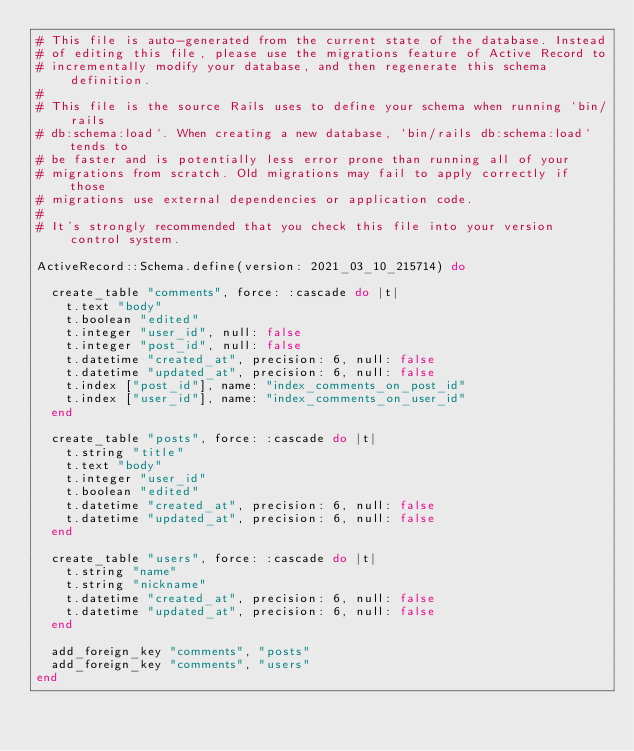Convert code to text. <code><loc_0><loc_0><loc_500><loc_500><_Ruby_># This file is auto-generated from the current state of the database. Instead
# of editing this file, please use the migrations feature of Active Record to
# incrementally modify your database, and then regenerate this schema definition.
#
# This file is the source Rails uses to define your schema when running `bin/rails
# db:schema:load`. When creating a new database, `bin/rails db:schema:load` tends to
# be faster and is potentially less error prone than running all of your
# migrations from scratch. Old migrations may fail to apply correctly if those
# migrations use external dependencies or application code.
#
# It's strongly recommended that you check this file into your version control system.

ActiveRecord::Schema.define(version: 2021_03_10_215714) do

  create_table "comments", force: :cascade do |t|
    t.text "body"
    t.boolean "edited"
    t.integer "user_id", null: false
    t.integer "post_id", null: false
    t.datetime "created_at", precision: 6, null: false
    t.datetime "updated_at", precision: 6, null: false
    t.index ["post_id"], name: "index_comments_on_post_id"
    t.index ["user_id"], name: "index_comments_on_user_id"
  end

  create_table "posts", force: :cascade do |t|
    t.string "title"
    t.text "body"
    t.integer "user_id"
    t.boolean "edited"
    t.datetime "created_at", precision: 6, null: false
    t.datetime "updated_at", precision: 6, null: false
  end

  create_table "users", force: :cascade do |t|
    t.string "name"
    t.string "nickname"
    t.datetime "created_at", precision: 6, null: false
    t.datetime "updated_at", precision: 6, null: false
  end

  add_foreign_key "comments", "posts"
  add_foreign_key "comments", "users"
end
</code> 